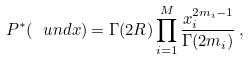Convert formula to latex. <formula><loc_0><loc_0><loc_500><loc_500>P ^ { \ast } ( \ u n d { x } ) = \Gamma ( 2 R ) \prod _ { i = 1 } ^ { M } \frac { x _ { i } ^ { 2 m _ { i } - 1 } } { \Gamma ( 2 m _ { i } ) } \, ,</formula> 